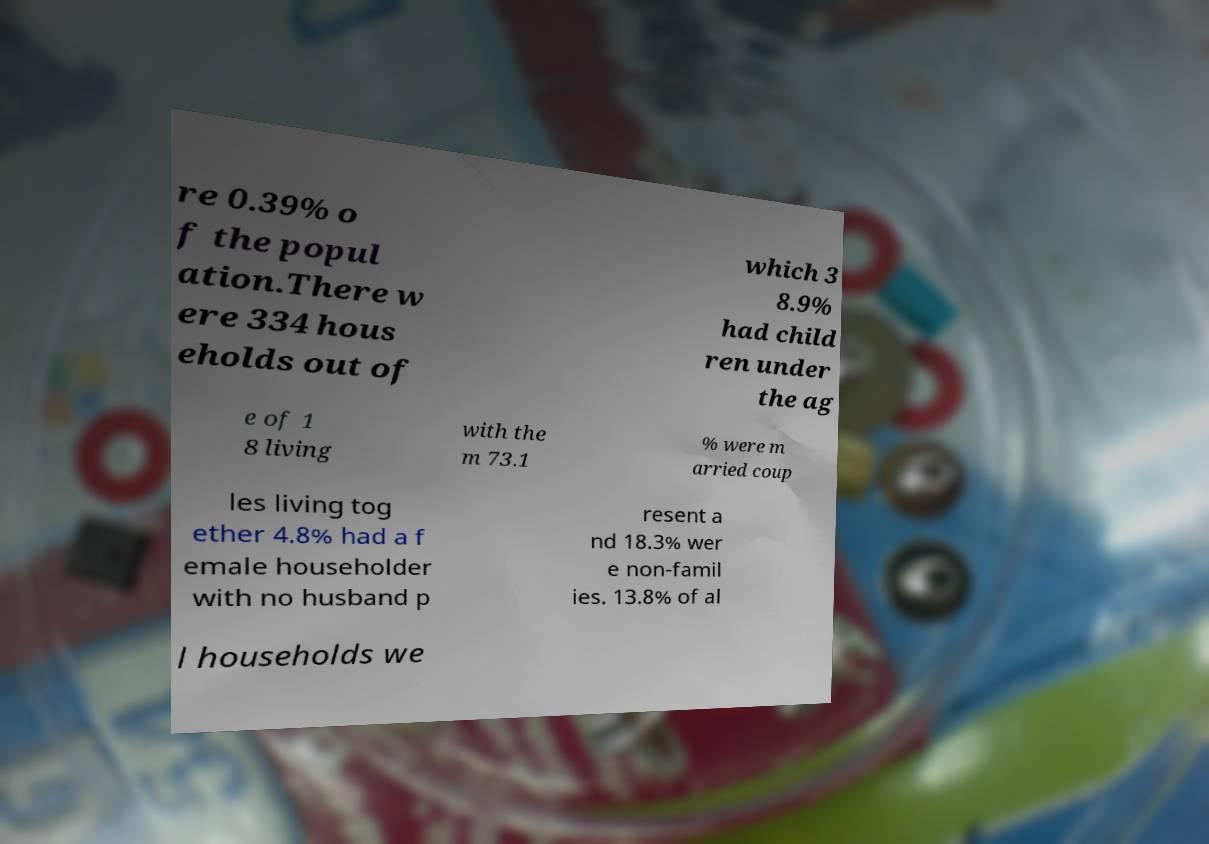Could you extract and type out the text from this image? re 0.39% o f the popul ation.There w ere 334 hous eholds out of which 3 8.9% had child ren under the ag e of 1 8 living with the m 73.1 % were m arried coup les living tog ether 4.8% had a f emale householder with no husband p resent a nd 18.3% wer e non-famil ies. 13.8% of al l households we 